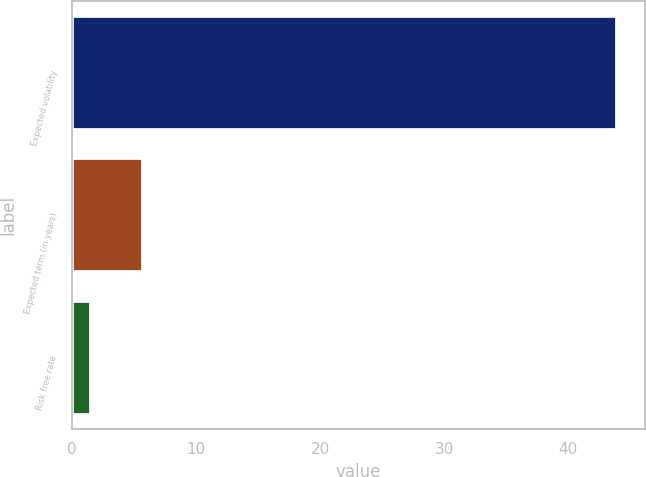Convert chart to OTSL. <chart><loc_0><loc_0><loc_500><loc_500><bar_chart><fcel>Expected volatility<fcel>Expected term (in years)<fcel>Risk free rate<nl><fcel>43.96<fcel>5.75<fcel>1.5<nl></chart> 